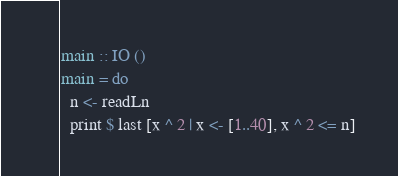Convert code to text. <code><loc_0><loc_0><loc_500><loc_500><_Haskell_>main :: IO ()
main = do
  n <- readLn
  print $ last [x ^ 2 | x <- [1..40], x ^ 2 <= n]</code> 